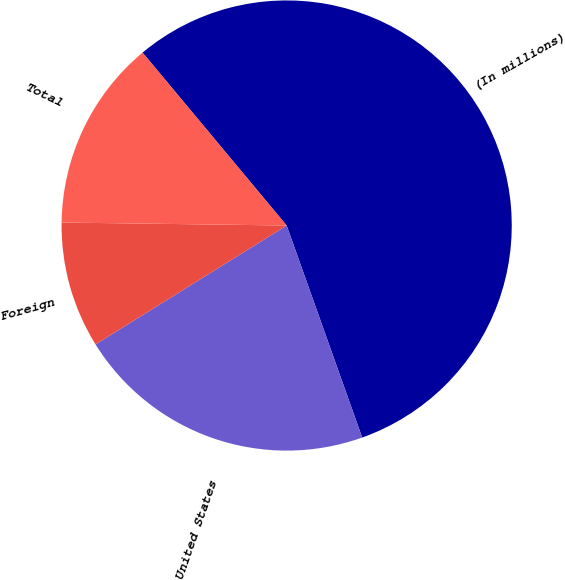<chart> <loc_0><loc_0><loc_500><loc_500><pie_chart><fcel>(In millions)<fcel>United States<fcel>Foreign<fcel>Total<nl><fcel>55.61%<fcel>21.59%<fcel>9.07%<fcel>13.73%<nl></chart> 